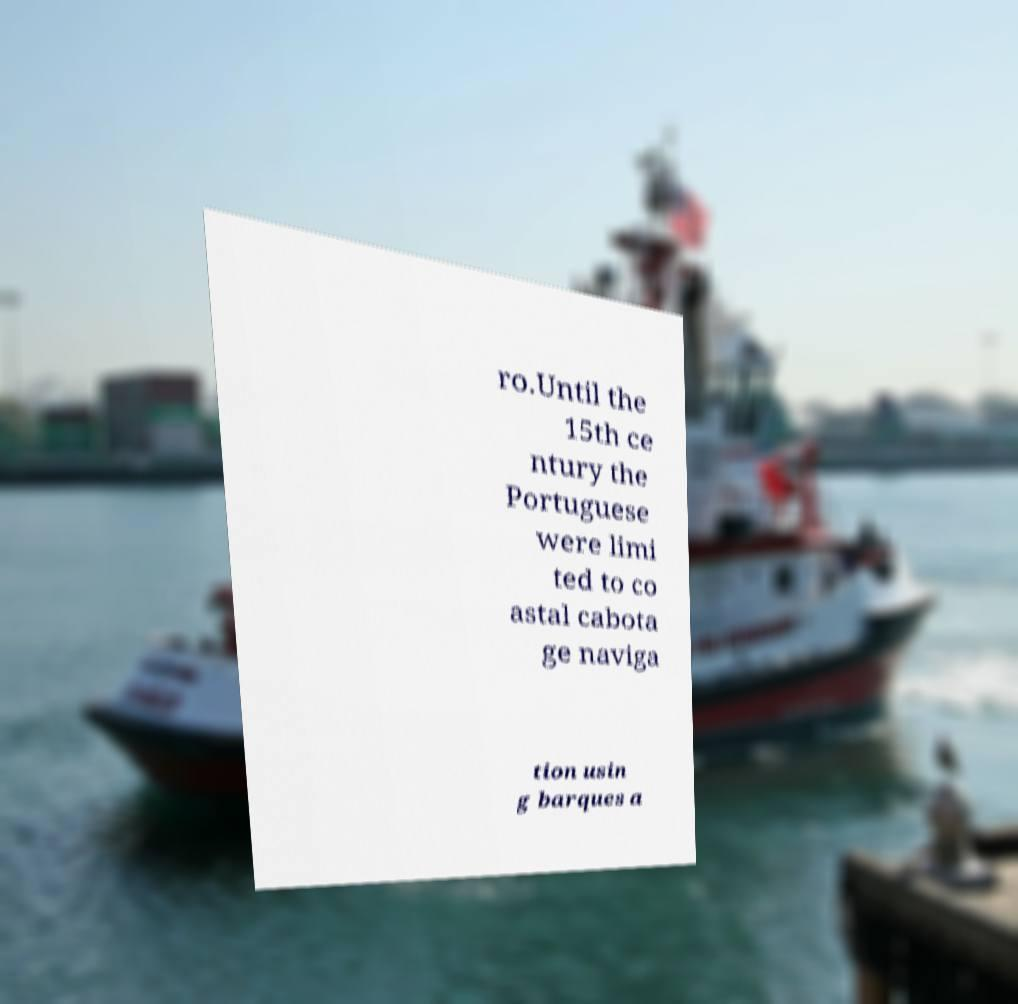Can you accurately transcribe the text from the provided image for me? ro.Until the 15th ce ntury the Portuguese were limi ted to co astal cabota ge naviga tion usin g barques a 